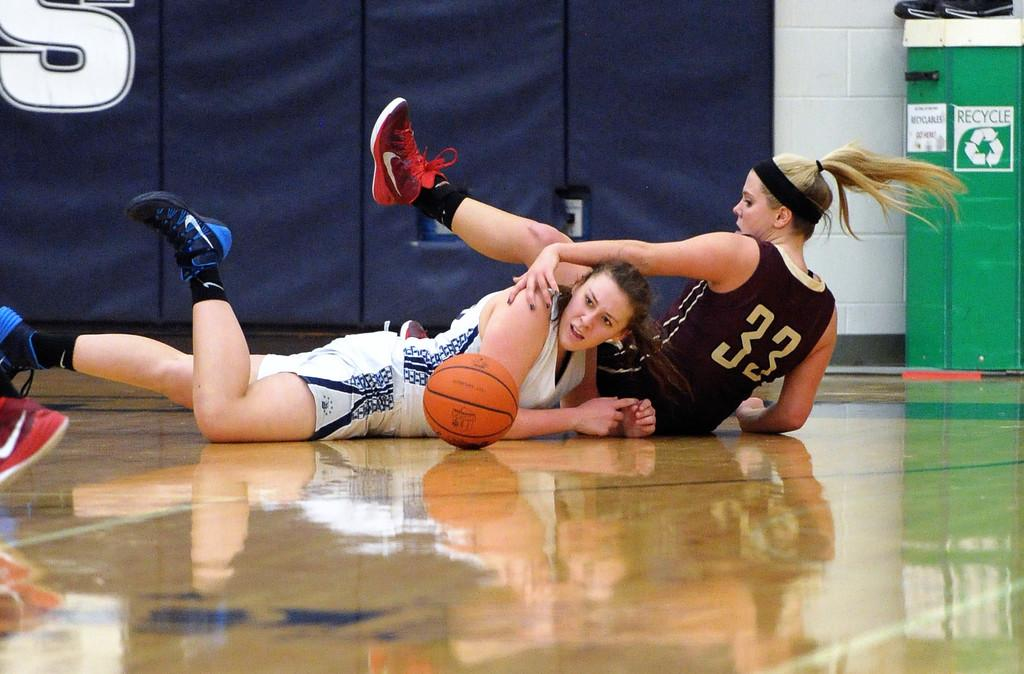<image>
Write a terse but informative summary of the picture. Two girls with the one in black wearing number 33 sitting down 